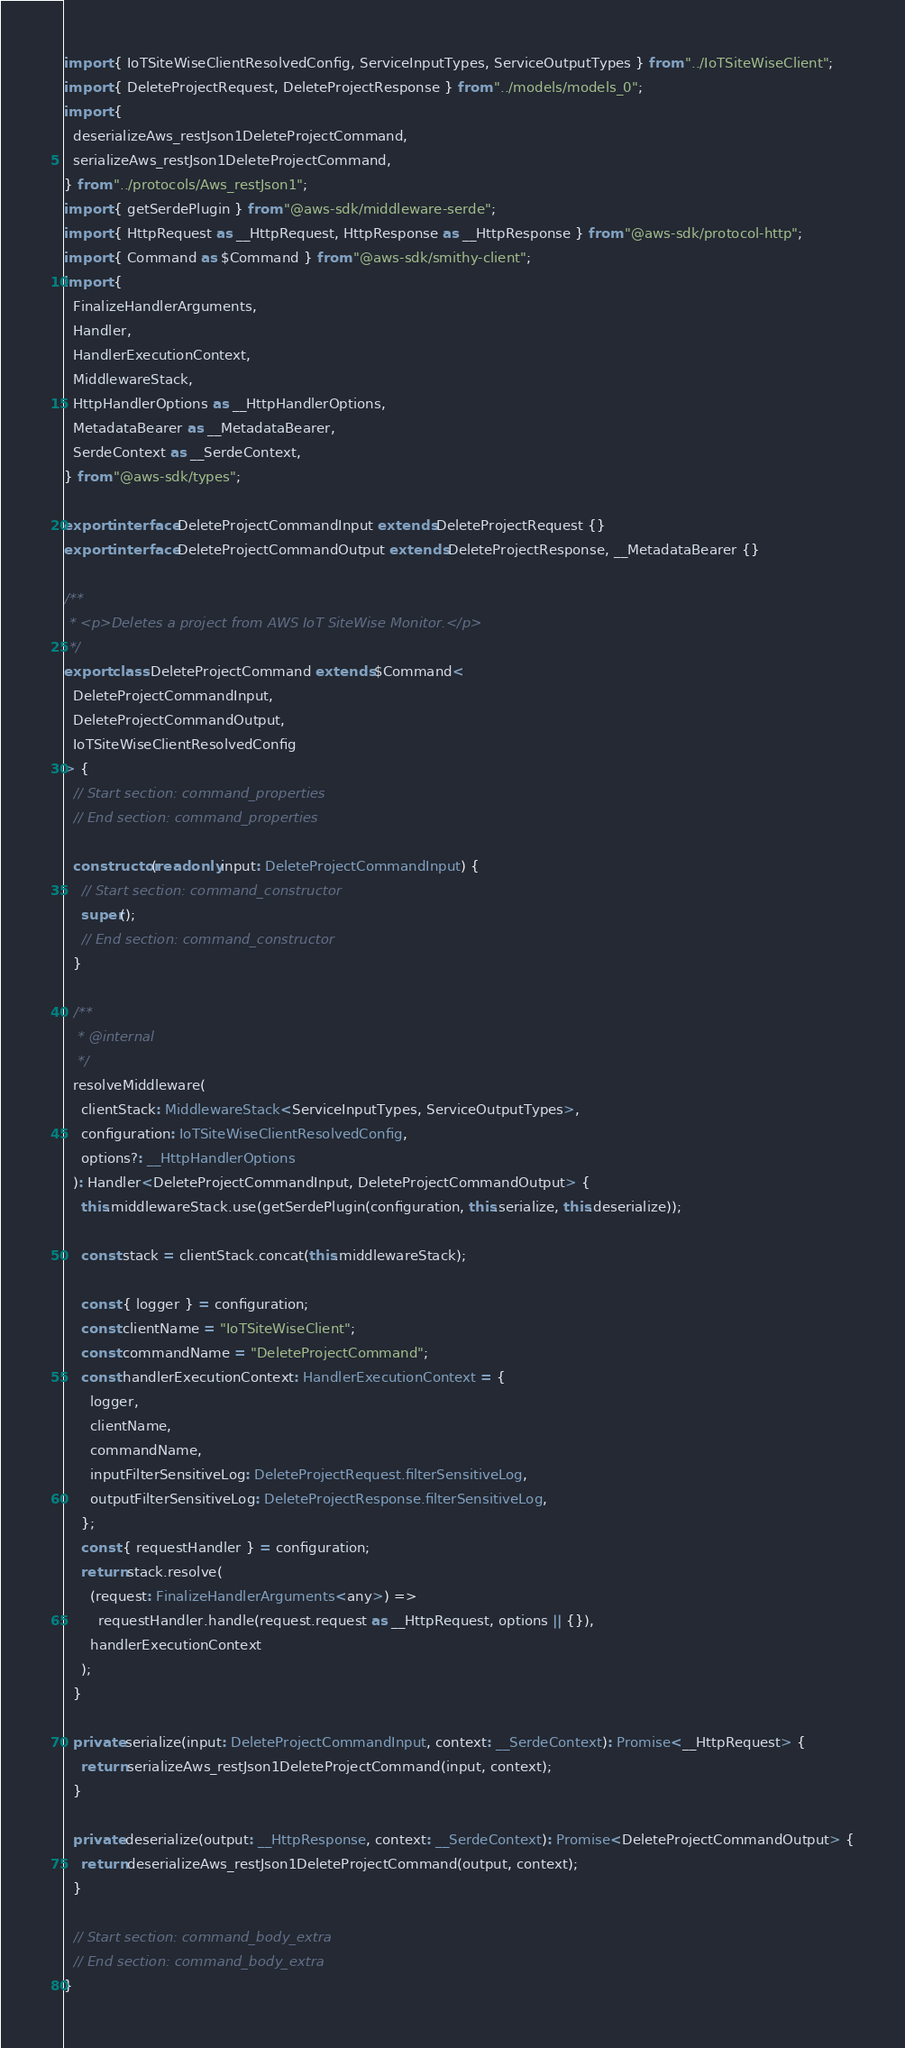<code> <loc_0><loc_0><loc_500><loc_500><_TypeScript_>import { IoTSiteWiseClientResolvedConfig, ServiceInputTypes, ServiceOutputTypes } from "../IoTSiteWiseClient";
import { DeleteProjectRequest, DeleteProjectResponse } from "../models/models_0";
import {
  deserializeAws_restJson1DeleteProjectCommand,
  serializeAws_restJson1DeleteProjectCommand,
} from "../protocols/Aws_restJson1";
import { getSerdePlugin } from "@aws-sdk/middleware-serde";
import { HttpRequest as __HttpRequest, HttpResponse as __HttpResponse } from "@aws-sdk/protocol-http";
import { Command as $Command } from "@aws-sdk/smithy-client";
import {
  FinalizeHandlerArguments,
  Handler,
  HandlerExecutionContext,
  MiddlewareStack,
  HttpHandlerOptions as __HttpHandlerOptions,
  MetadataBearer as __MetadataBearer,
  SerdeContext as __SerdeContext,
} from "@aws-sdk/types";

export interface DeleteProjectCommandInput extends DeleteProjectRequest {}
export interface DeleteProjectCommandOutput extends DeleteProjectResponse, __MetadataBearer {}

/**
 * <p>Deletes a project from AWS IoT SiteWise Monitor.</p>
 */
export class DeleteProjectCommand extends $Command<
  DeleteProjectCommandInput,
  DeleteProjectCommandOutput,
  IoTSiteWiseClientResolvedConfig
> {
  // Start section: command_properties
  // End section: command_properties

  constructor(readonly input: DeleteProjectCommandInput) {
    // Start section: command_constructor
    super();
    // End section: command_constructor
  }

  /**
   * @internal
   */
  resolveMiddleware(
    clientStack: MiddlewareStack<ServiceInputTypes, ServiceOutputTypes>,
    configuration: IoTSiteWiseClientResolvedConfig,
    options?: __HttpHandlerOptions
  ): Handler<DeleteProjectCommandInput, DeleteProjectCommandOutput> {
    this.middlewareStack.use(getSerdePlugin(configuration, this.serialize, this.deserialize));

    const stack = clientStack.concat(this.middlewareStack);

    const { logger } = configuration;
    const clientName = "IoTSiteWiseClient";
    const commandName = "DeleteProjectCommand";
    const handlerExecutionContext: HandlerExecutionContext = {
      logger,
      clientName,
      commandName,
      inputFilterSensitiveLog: DeleteProjectRequest.filterSensitiveLog,
      outputFilterSensitiveLog: DeleteProjectResponse.filterSensitiveLog,
    };
    const { requestHandler } = configuration;
    return stack.resolve(
      (request: FinalizeHandlerArguments<any>) =>
        requestHandler.handle(request.request as __HttpRequest, options || {}),
      handlerExecutionContext
    );
  }

  private serialize(input: DeleteProjectCommandInput, context: __SerdeContext): Promise<__HttpRequest> {
    return serializeAws_restJson1DeleteProjectCommand(input, context);
  }

  private deserialize(output: __HttpResponse, context: __SerdeContext): Promise<DeleteProjectCommandOutput> {
    return deserializeAws_restJson1DeleteProjectCommand(output, context);
  }

  // Start section: command_body_extra
  // End section: command_body_extra
}
</code> 